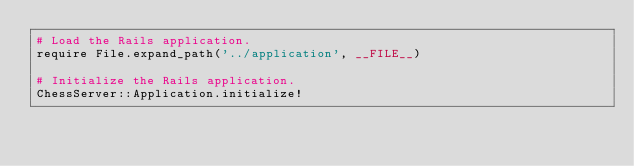<code> <loc_0><loc_0><loc_500><loc_500><_Ruby_># Load the Rails application.
require File.expand_path('../application', __FILE__)

# Initialize the Rails application.
ChessServer::Application.initialize!
</code> 